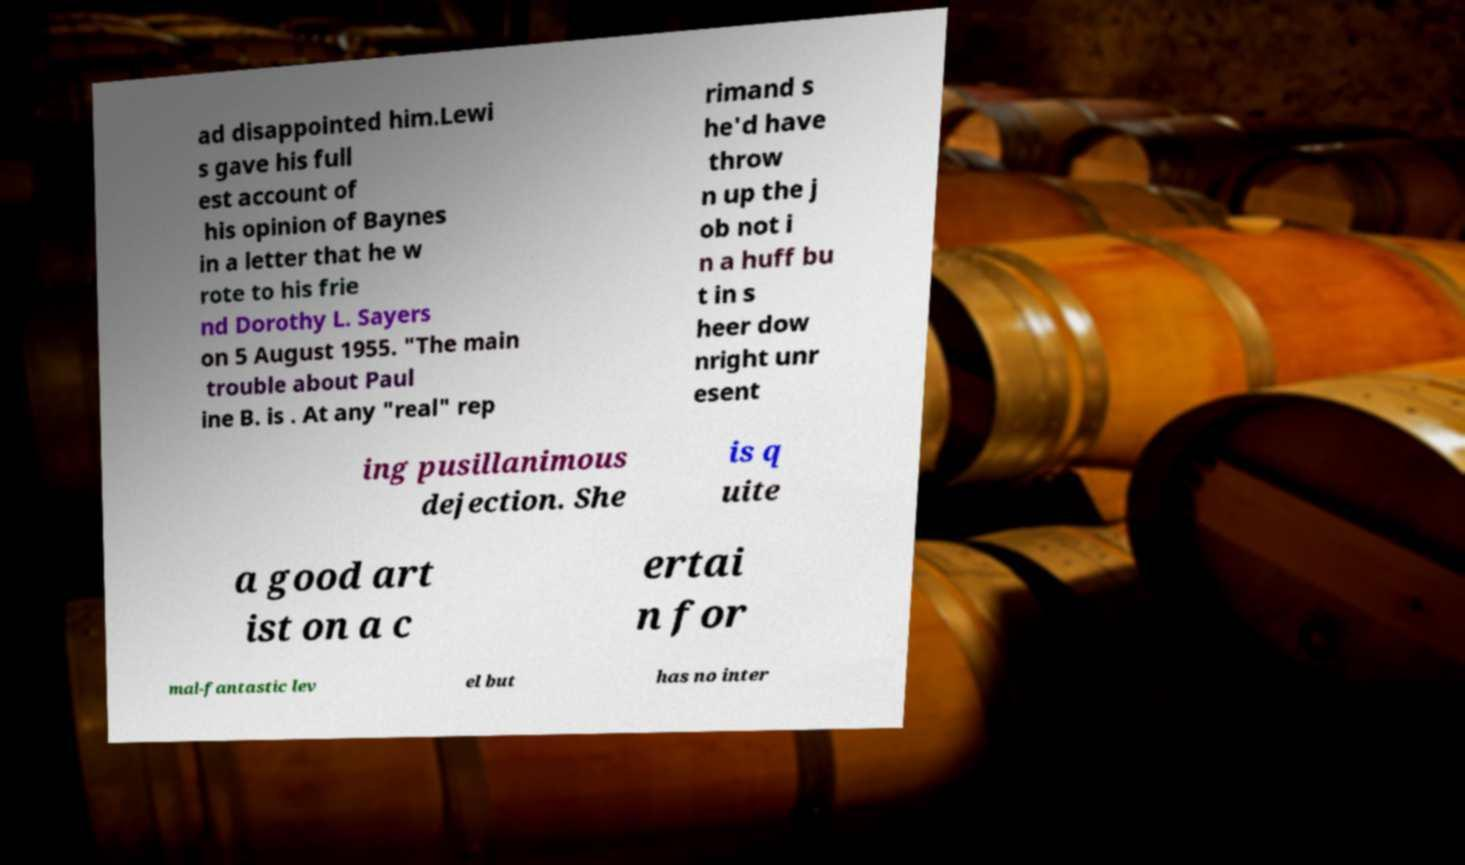Can you accurately transcribe the text from the provided image for me? ad disappointed him.Lewi s gave his full est account of his opinion of Baynes in a letter that he w rote to his frie nd Dorothy L. Sayers on 5 August 1955. "The main trouble about Paul ine B. is . At any "real" rep rimand s he'd have throw n up the j ob not i n a huff bu t in s heer dow nright unr esent ing pusillanimous dejection. She is q uite a good art ist on a c ertai n for mal-fantastic lev el but has no inter 